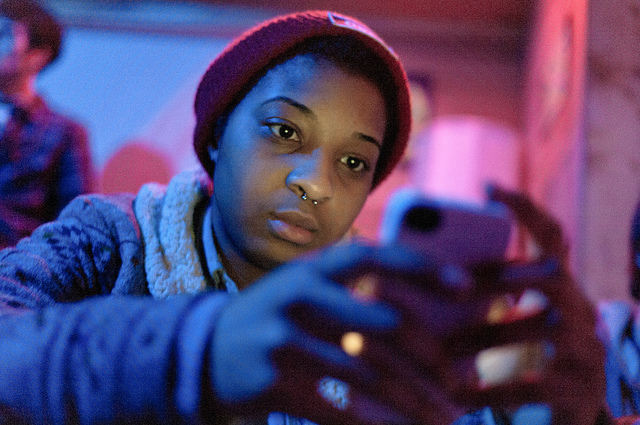<image>What sport is he playing? The person is not playing any sport. What is the design on her phone? I don't know the design on her phone. It could be 'solid', 'pink', 'plain', 'case', 'solid color', 'solid white' or 'brick'. What sport is he playing? I am not sure what sport he is playing. It can be seen that he is playing basketball or boxing. What is the design on her phone? I am not sure what the design on her phone is. It can be seen as solid color or plain. 